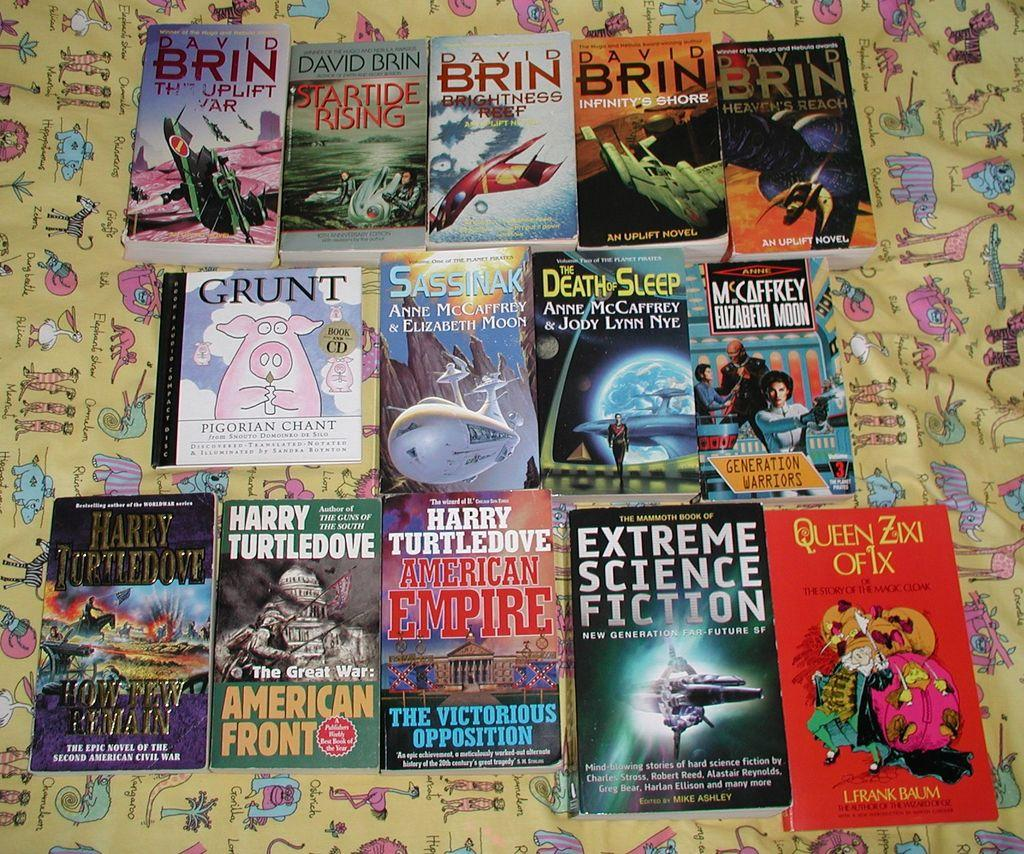Provide a one-sentence caption for the provided image. Books on a blanket including Extreme Science Fiction. 